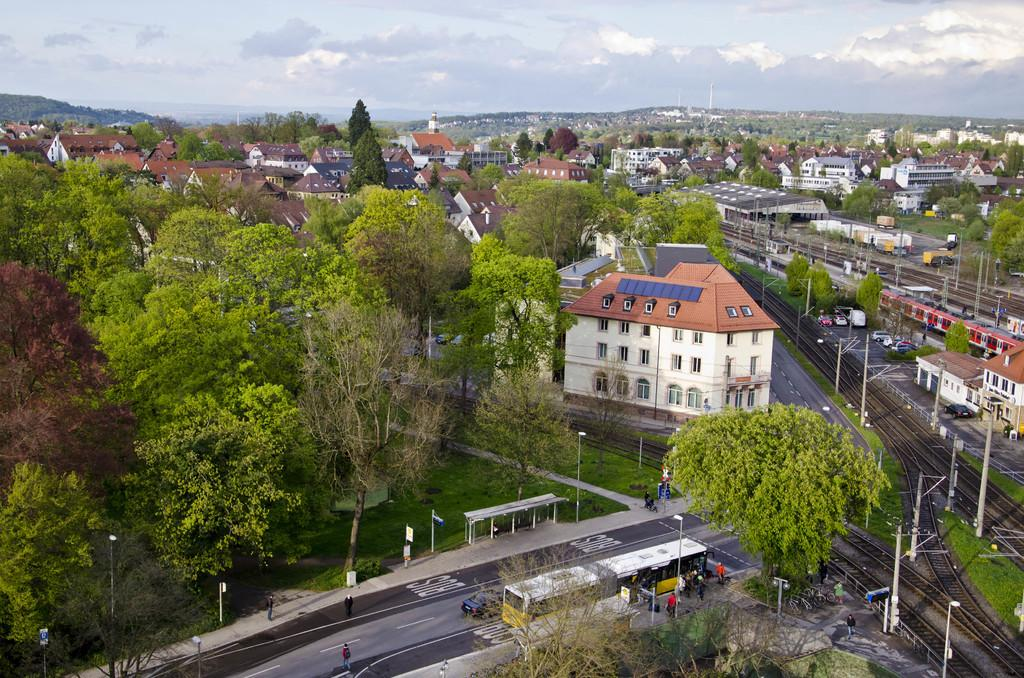What type of structures can be seen in the image? There are many buildings in the image. What is happening on the road in the image? Vehicles are moving on the road in the image. What transportation feature is present in the image? There is a railway track in the image. What type of natural elements can be seen in the image? Trees are present in the image. From what perspective is the image taken? The image is taken from a top view. Can you tell me how many kites are flying in the image? There are no kites present in the image. How many knots are tied on the railway track in the image? There are no knots on the railway track in the image; it is a continuous track. 